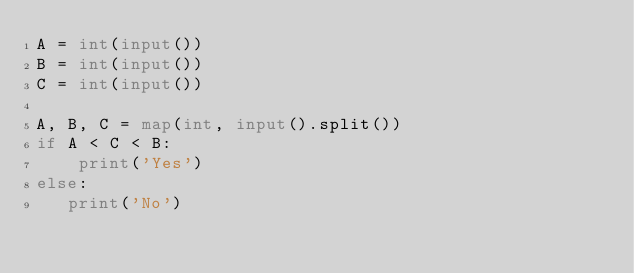<code> <loc_0><loc_0><loc_500><loc_500><_Python_>A = int(input())
B = int(input())
C = int(input())

A, B, C = map(int, input().split())
if A < C < B:
    print('Yes')
else:
   print('No')</code> 